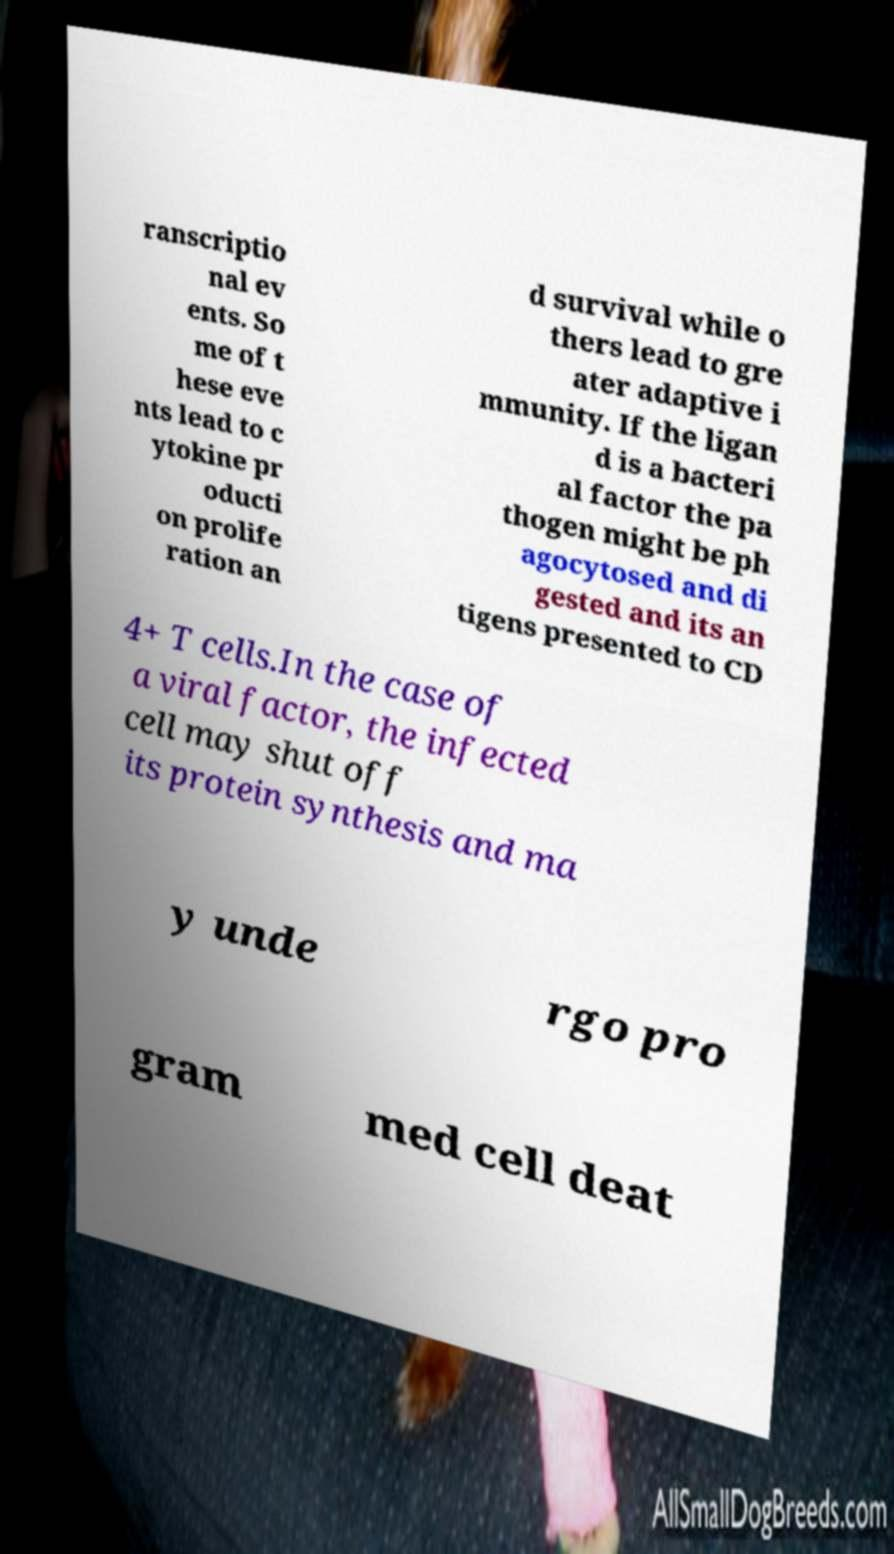Please read and relay the text visible in this image. What does it say? ranscriptio nal ev ents. So me of t hese eve nts lead to c ytokine pr oducti on prolife ration an d survival while o thers lead to gre ater adaptive i mmunity. If the ligan d is a bacteri al factor the pa thogen might be ph agocytosed and di gested and its an tigens presented to CD 4+ T cells.In the case of a viral factor, the infected cell may shut off its protein synthesis and ma y unde rgo pro gram med cell deat 